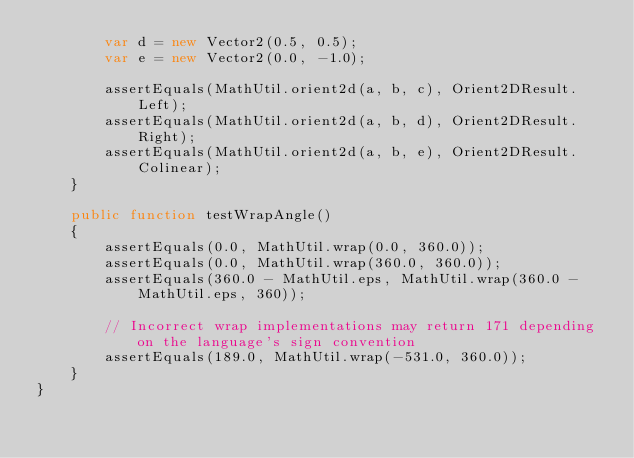Convert code to text. <code><loc_0><loc_0><loc_500><loc_500><_Haxe_>        var d = new Vector2(0.5, 0.5);
        var e = new Vector2(0.0, -1.0);
        
        assertEquals(MathUtil.orient2d(a, b, c), Orient2DResult.Left);
        assertEquals(MathUtil.orient2d(a, b, d), Orient2DResult.Right);
        assertEquals(MathUtil.orient2d(a, b, e), Orient2DResult.Colinear);
    }
    
    public function testWrapAngle()
    {
        assertEquals(0.0, MathUtil.wrap(0.0, 360.0));
        assertEquals(0.0, MathUtil.wrap(360.0, 360.0));
        assertEquals(360.0 - MathUtil.eps, MathUtil.wrap(360.0 - MathUtil.eps, 360));
        
        // Incorrect wrap implementations may return 171 depending on the language's sign convention
        assertEquals(189.0, MathUtil.wrap(-531.0, 360.0));
    }
}</code> 